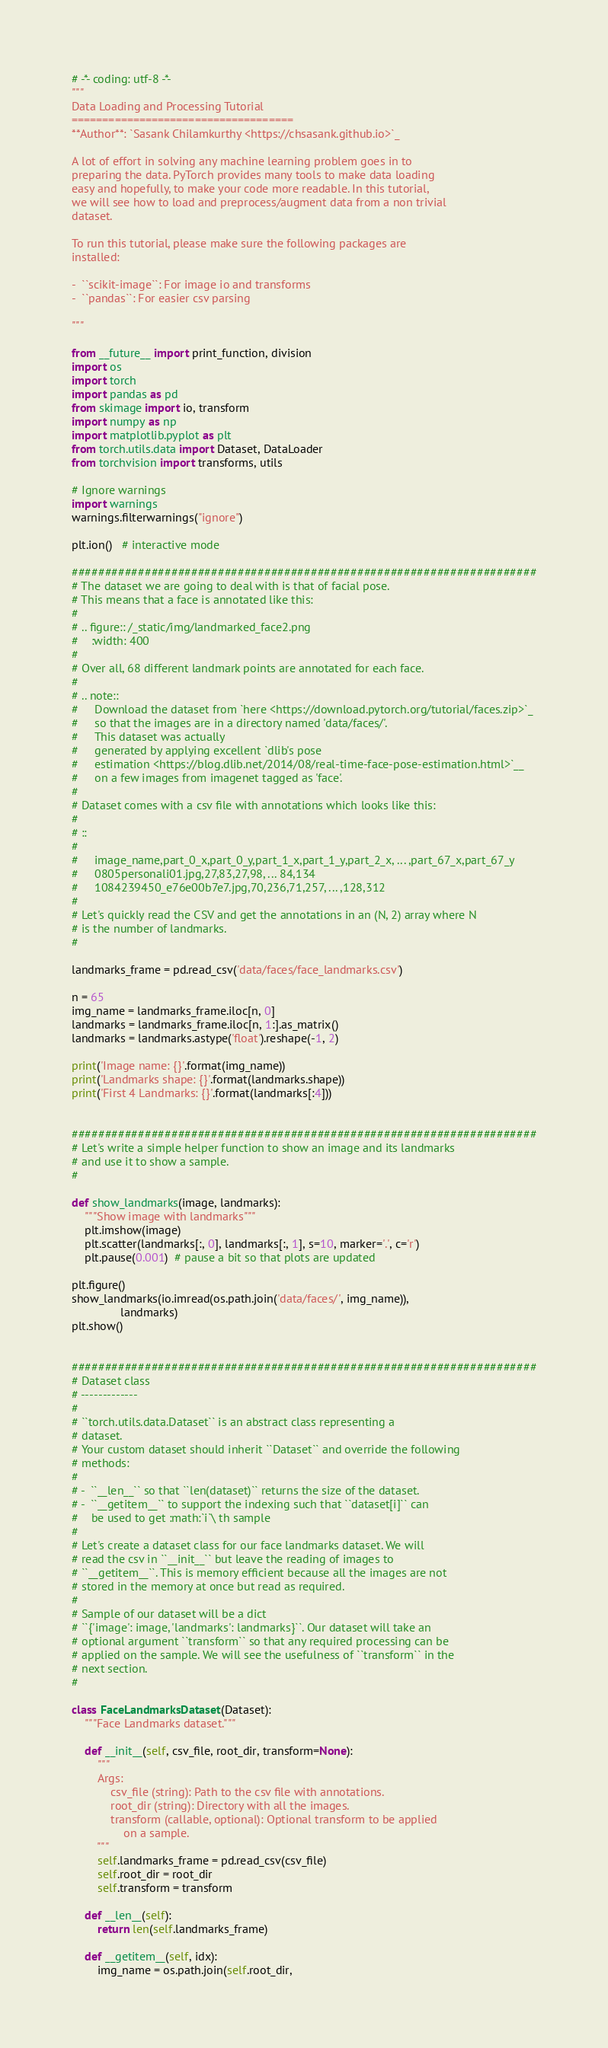Convert code to text. <code><loc_0><loc_0><loc_500><loc_500><_Python_># -*- coding: utf-8 -*-
"""
Data Loading and Processing Tutorial
====================================
**Author**: `Sasank Chilamkurthy <https://chsasank.github.io>`_

A lot of effort in solving any machine learning problem goes in to
preparing the data. PyTorch provides many tools to make data loading
easy and hopefully, to make your code more readable. In this tutorial,
we will see how to load and preprocess/augment data from a non trivial
dataset.

To run this tutorial, please make sure the following packages are
installed:

-  ``scikit-image``: For image io and transforms
-  ``pandas``: For easier csv parsing

"""

from __future__ import print_function, division
import os
import torch
import pandas as pd
from skimage import io, transform
import numpy as np
import matplotlib.pyplot as plt
from torch.utils.data import Dataset, DataLoader
from torchvision import transforms, utils

# Ignore warnings
import warnings
warnings.filterwarnings("ignore")

plt.ion()   # interactive mode

######################################################################
# The dataset we are going to deal with is that of facial pose.
# This means that a face is annotated like this:
#
# .. figure:: /_static/img/landmarked_face2.png
#    :width: 400
#
# Over all, 68 different landmark points are annotated for each face.
#
# .. note::
#     Download the dataset from `here <https://download.pytorch.org/tutorial/faces.zip>`_
#     so that the images are in a directory named 'data/faces/'.
#     This dataset was actually
#     generated by applying excellent `dlib's pose
#     estimation <https://blog.dlib.net/2014/08/real-time-face-pose-estimation.html>`__
#     on a few images from imagenet tagged as 'face'.
#
# Dataset comes with a csv file with annotations which looks like this:
#
# ::
#
#     image_name,part_0_x,part_0_y,part_1_x,part_1_y,part_2_x, ... ,part_67_x,part_67_y
#     0805personali01.jpg,27,83,27,98, ... 84,134
#     1084239450_e76e00b7e7.jpg,70,236,71,257, ... ,128,312
#
# Let's quickly read the CSV and get the annotations in an (N, 2) array where N
# is the number of landmarks.
#

landmarks_frame = pd.read_csv('data/faces/face_landmarks.csv')

n = 65
img_name = landmarks_frame.iloc[n, 0]
landmarks = landmarks_frame.iloc[n, 1:].as_matrix()
landmarks = landmarks.astype('float').reshape(-1, 2)

print('Image name: {}'.format(img_name))
print('Landmarks shape: {}'.format(landmarks.shape))
print('First 4 Landmarks: {}'.format(landmarks[:4]))


######################################################################
# Let's write a simple helper function to show an image and its landmarks
# and use it to show a sample.
#

def show_landmarks(image, landmarks):
    """Show image with landmarks"""
    plt.imshow(image)
    plt.scatter(landmarks[:, 0], landmarks[:, 1], s=10, marker='.', c='r')
    plt.pause(0.001)  # pause a bit so that plots are updated

plt.figure()
show_landmarks(io.imread(os.path.join('data/faces/', img_name)),
               landmarks)
plt.show()


######################################################################
# Dataset class
# -------------
#
# ``torch.utils.data.Dataset`` is an abstract class representing a
# dataset.
# Your custom dataset should inherit ``Dataset`` and override the following
# methods:
#
# -  ``__len__`` so that ``len(dataset)`` returns the size of the dataset.
# -  ``__getitem__`` to support the indexing such that ``dataset[i]`` can
#    be used to get :math:`i`\ th sample
#
# Let's create a dataset class for our face landmarks dataset. We will
# read the csv in ``__init__`` but leave the reading of images to
# ``__getitem__``. This is memory efficient because all the images are not
# stored in the memory at once but read as required.
#
# Sample of our dataset will be a dict
# ``{'image': image, 'landmarks': landmarks}``. Our dataset will take an
# optional argument ``transform`` so that any required processing can be
# applied on the sample. We will see the usefulness of ``transform`` in the
# next section.
#

class FaceLandmarksDataset(Dataset):
    """Face Landmarks dataset."""

    def __init__(self, csv_file, root_dir, transform=None):
        """
        Args:
            csv_file (string): Path to the csv file with annotations.
            root_dir (string): Directory with all the images.
            transform (callable, optional): Optional transform to be applied
                on a sample.
        """
        self.landmarks_frame = pd.read_csv(csv_file)
        self.root_dir = root_dir
        self.transform = transform

    def __len__(self):
        return len(self.landmarks_frame)

    def __getitem__(self, idx):
        img_name = os.path.join(self.root_dir,</code> 